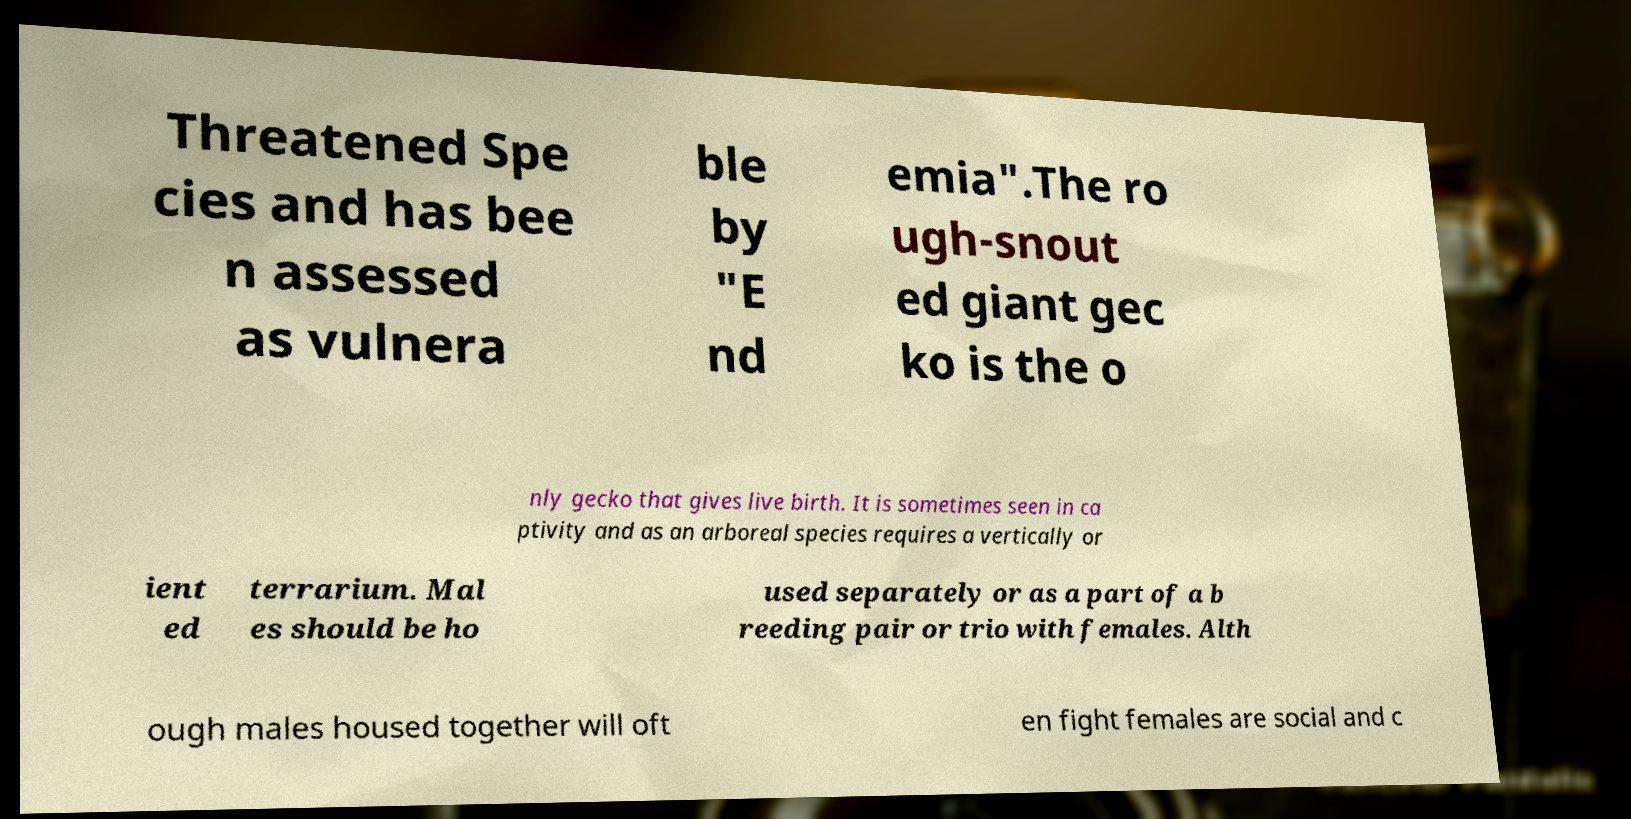For documentation purposes, I need the text within this image transcribed. Could you provide that? Threatened Spe cies and has bee n assessed as vulnera ble by "E nd emia".The ro ugh-snout ed giant gec ko is the o nly gecko that gives live birth. It is sometimes seen in ca ptivity and as an arboreal species requires a vertically or ient ed terrarium. Mal es should be ho used separately or as a part of a b reeding pair or trio with females. Alth ough males housed together will oft en fight females are social and c 